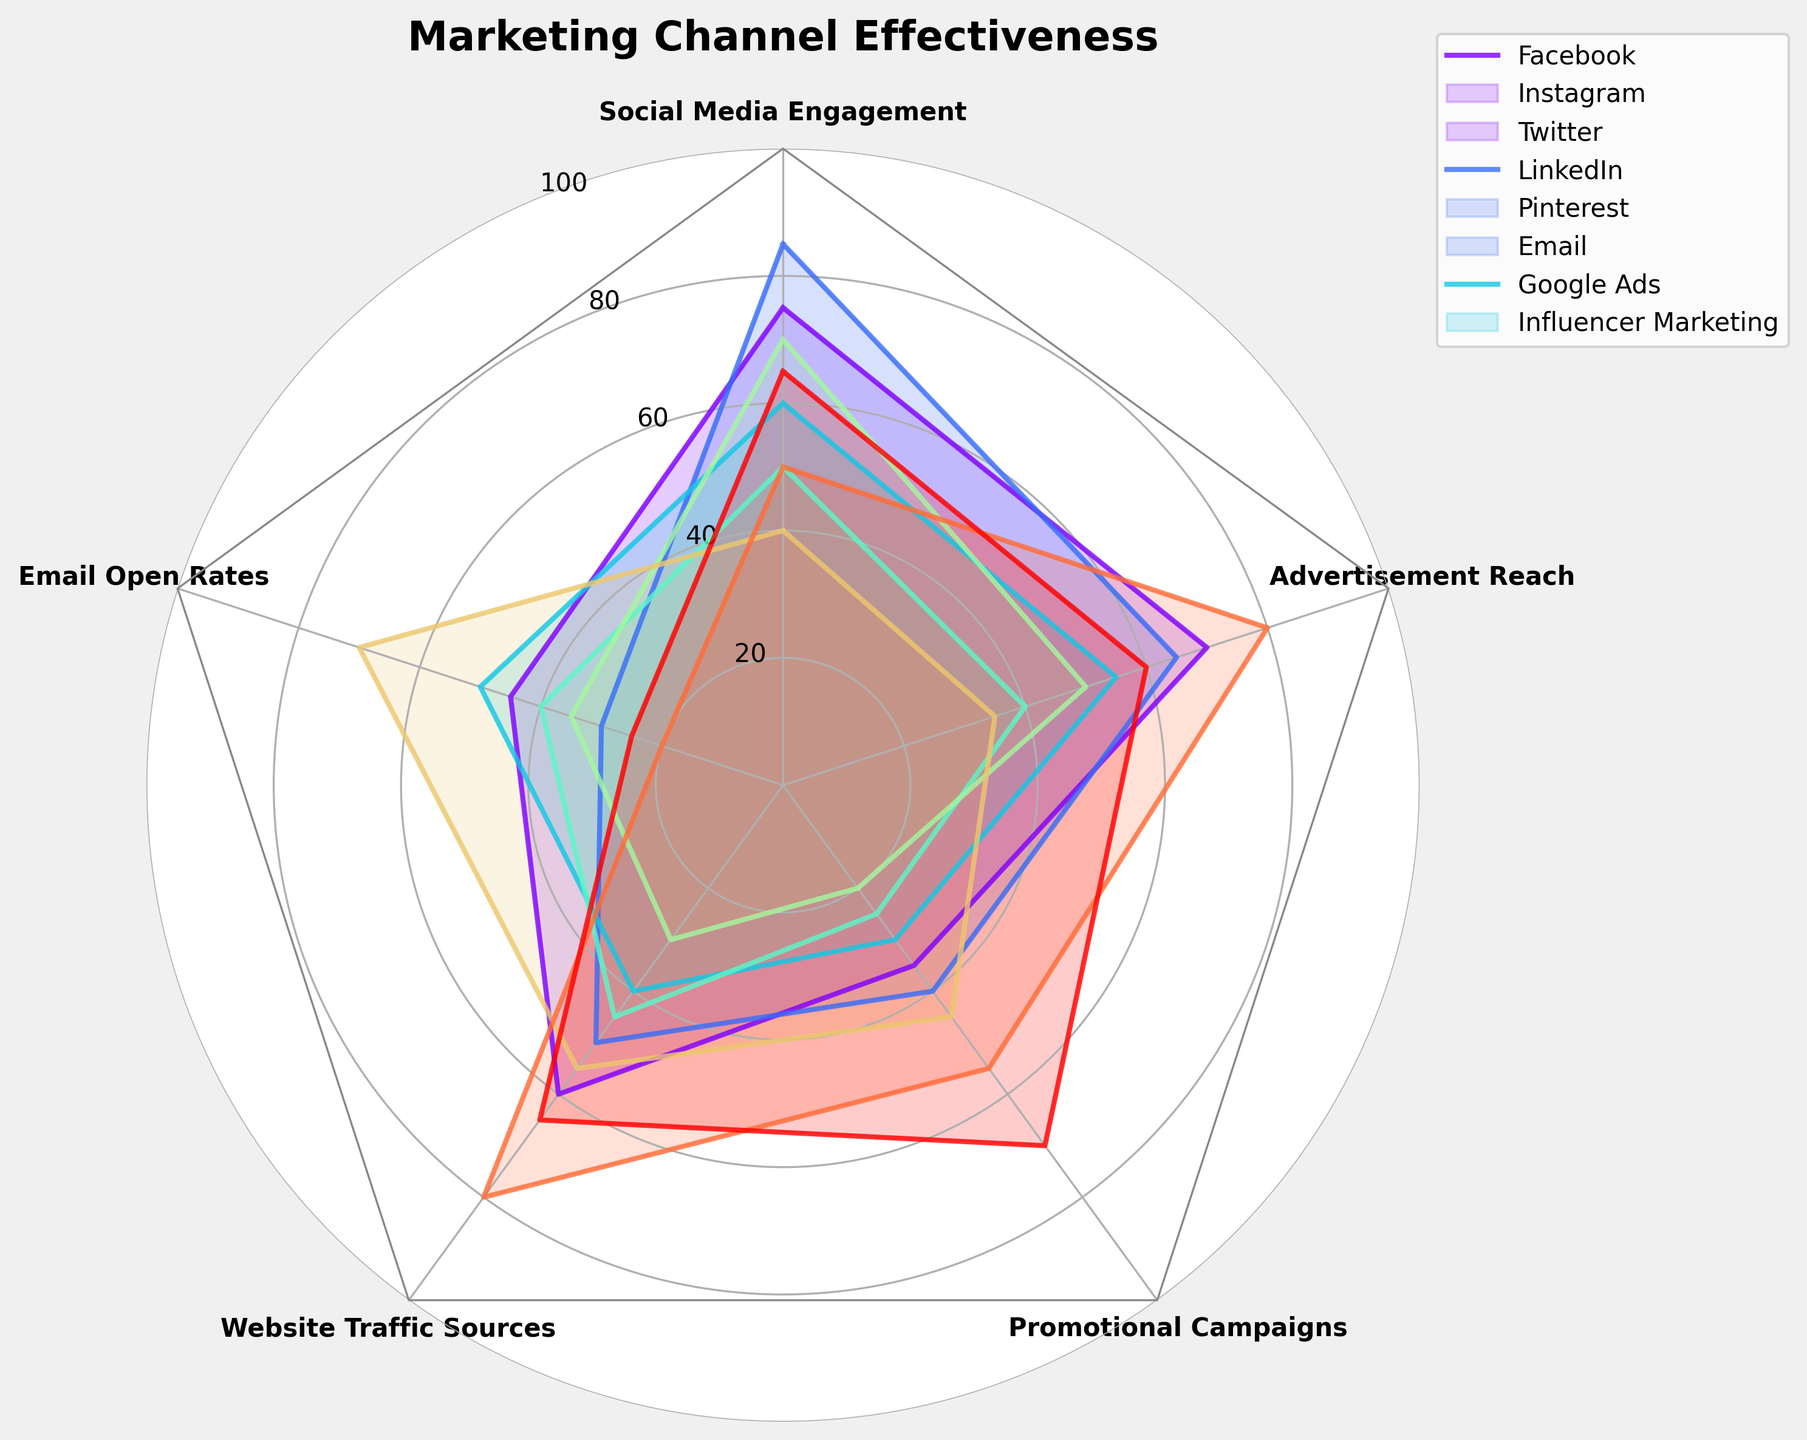What is the title of the radar chart? The title is generally positioned above the chart and directly states the main topic of the figure. It helps viewers quickly understand what the chart is about.
Answer: Marketing Channel Effectiveness Which marketing channel has the highest social media engagement? Social media engagement is one of the axes of the chart. By following the axis labeled "Social Media Engagement" and looking for the highest point among the plotted lines, you can determine which channel has the highest engagement.
Answer: Instagram Among the listed marketing channels, which one has the lowest advertisement reach? Advertisement reach is another axis of the radar chart. You need to look at the values along this axis and find the lowest point among the plotted lines.
Answer: Email What is the average email open rate among all channels? Email open rates for all channels are listed along one axis of the radar chart. To find the average, add up the email open rates for all channels and divide by the number of channels: (45 + 30 + 50 + 40 + 35 + 70 + 20 + 25) / 8 = 315 / 8.
Answer: 39.375 Which marketing channel has the highest value for website traffic sources, and what is that value? Look along the axis labeled "Website Traffic Sources" and find the highest point and the corresponding channel. Google Ads has the highest value for this metric.
Answer: Google Ads, 80 How does Twitter compare to LinkedIn in terms of promotional campaigns and advertisement reach? Promotional campaigns and advertisement reach for Twitter and LinkedIn are shown along their respective axes. By comparing the values, you can determine which has higher or lower values. Twitter: 30 (Promotional Campaigns), 55 (Advertisement Reach). LinkedIn: 25 (Promotional Campaigns), 40 (Advertisement Reach). Twitter has higher values for both metrics.
Answer: Twitter has higher values for both metrics Which marketing channel shows the highest value for promotional campaigns? Look along the axis labeled "Promotional Campaigns" to find the highest value among the plotted lines.
Answer: Influencer Marketing What is the average effectiveness across all metrics for Facebook? Sum the effectiveness values for Facebook across all metrics and divide by the number of metrics: (75 + 45 + 60 + 35 + 70) / 5 = 285 / 5.
Answer: 57 Which channel has more website traffic sources, Pinterest or Email? Compare the values along the axis labeled "Website Traffic Sources" for both Pinterest and Email. Pinterest has a lower value of 30, while Email has a value of 55.
Answer: Email What is the total value of advertisement reach for Instagram and Google Ads combined? Add the values of advertisement reach for Instagram and Google Ads: 65 (Instagram) + 80 (Google Ads).
Answer: 145 